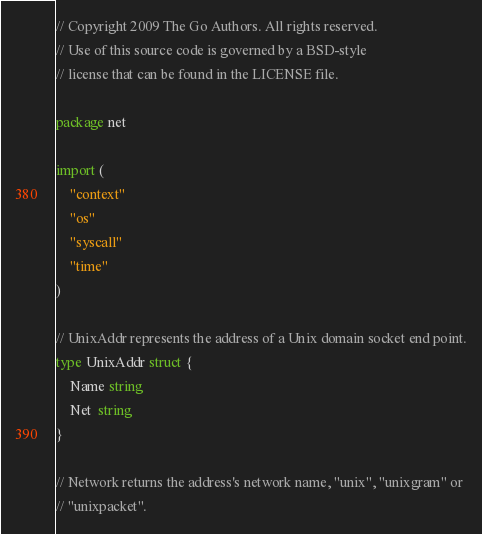Convert code to text. <code><loc_0><loc_0><loc_500><loc_500><_Go_>// Copyright 2009 The Go Authors. All rights reserved.
// Use of this source code is governed by a BSD-style
// license that can be found in the LICENSE file.

package net

import (
	"context"
	"os"
	"syscall"
	"time"
)

// UnixAddr represents the address of a Unix domain socket end point.
type UnixAddr struct {
	Name string
	Net  string
}

// Network returns the address's network name, "unix", "unixgram" or
// "unixpacket".</code> 